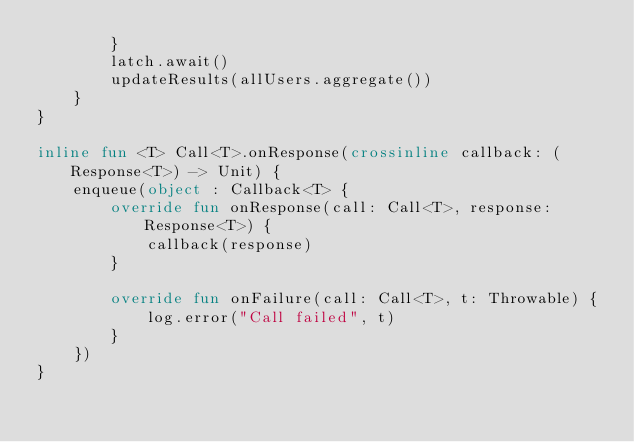<code> <loc_0><loc_0><loc_500><loc_500><_Kotlin_>        }
        latch.await()
        updateResults(allUsers.aggregate())
    }
}

inline fun <T> Call<T>.onResponse(crossinline callback: (Response<T>) -> Unit) {
    enqueue(object : Callback<T> {
        override fun onResponse(call: Call<T>, response: Response<T>) {
            callback(response)
        }

        override fun onFailure(call: Call<T>, t: Throwable) {
            log.error("Call failed", t)
        }
    })
}
</code> 